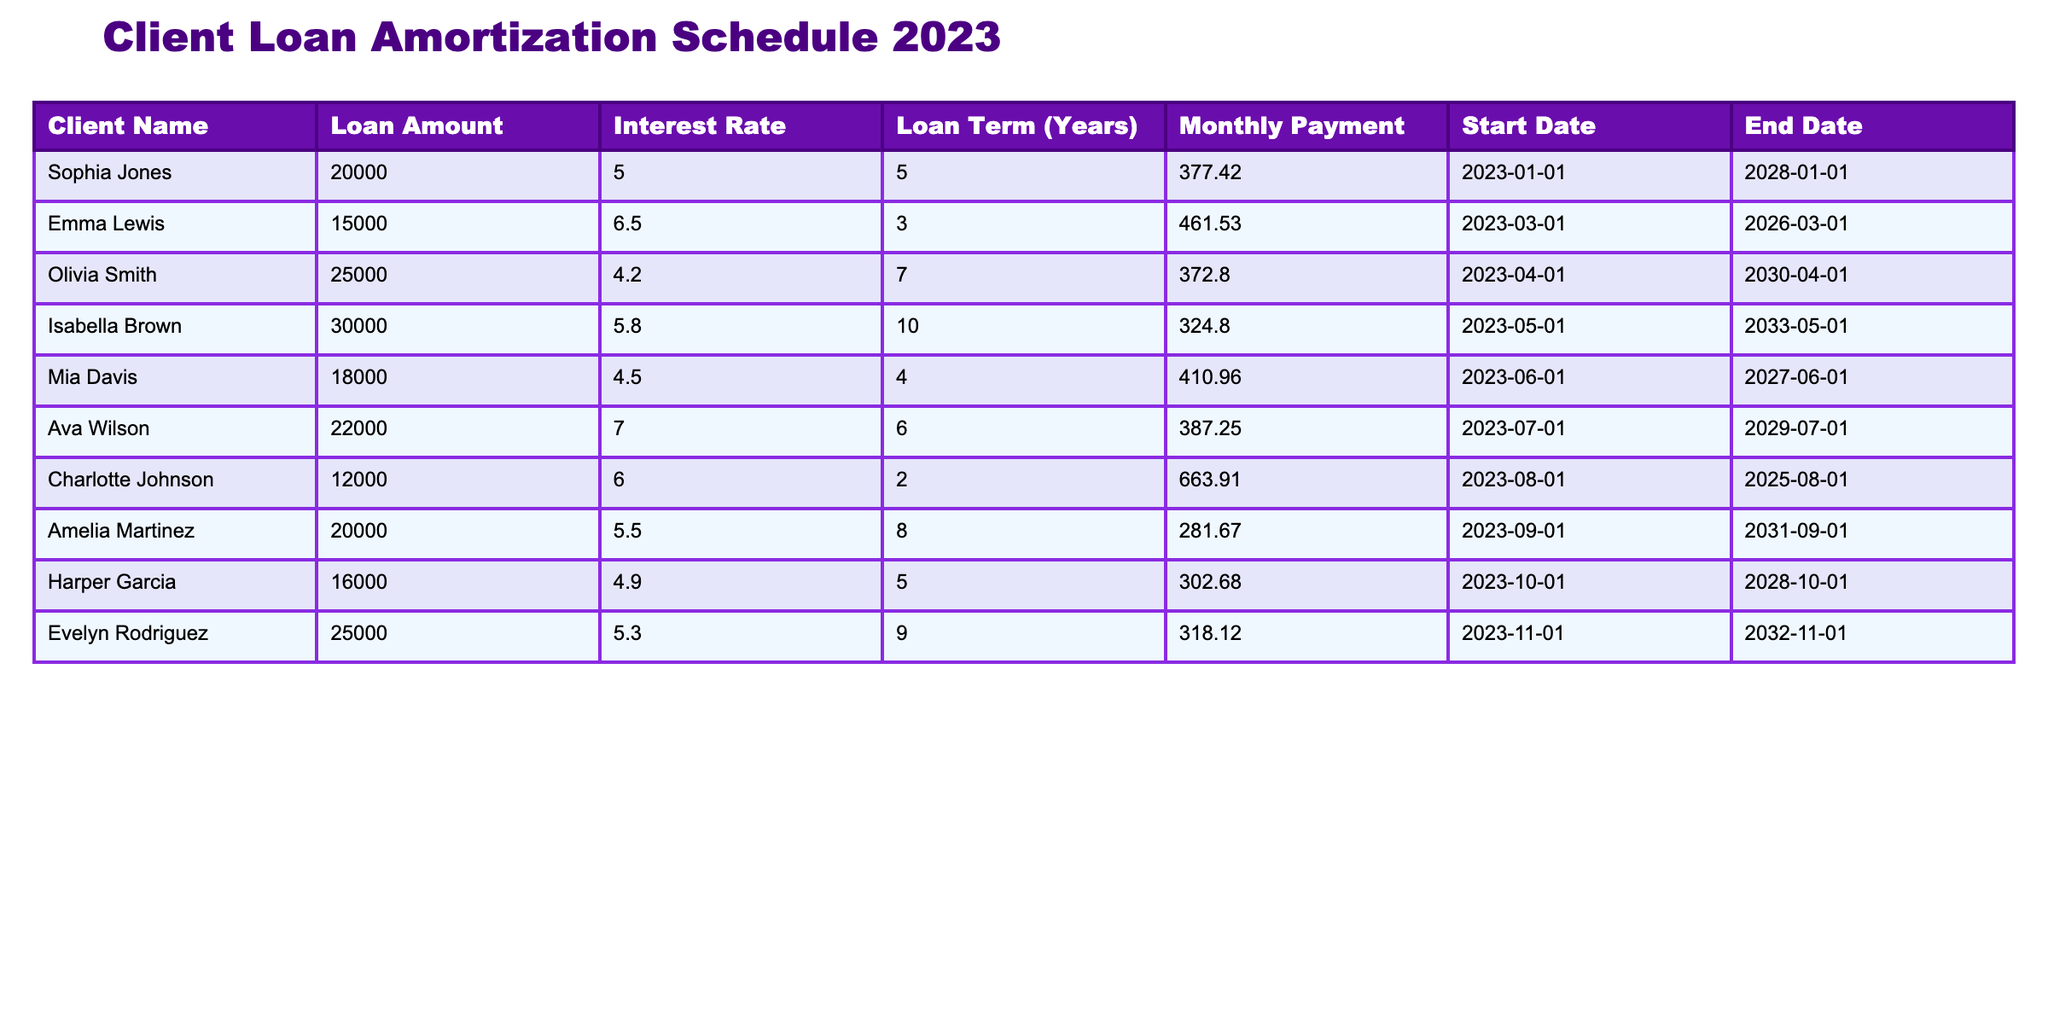What is the loan amount for Emma Lewis? The table lists the loan amounts for each client. Looking at Emma Lewis's row, her loan amount is clearly stated as 15000.
Answer: 15000 What is the monthly payment for Sophia Jones? To find this, we simply look at Sophia Jones's row in the table, where the monthly payment is noted as 377.42.
Answer: 377.42 Which client has the longest loan term? The loan terms are listed in years for each client. By scanning through the loan term, Isabella Brown has a loan term of 10 years, which is the longest compared to others.
Answer: Isabella Brown What is the total loan amount for all clients? We sum the loan amounts listed in the table: 20000 + 15000 + 25000 + 30000 + 18000 + 22000 + 12000 + 20000 + 16000 + 25000 = 188000. Therefore, the total loan amount for all clients is 188000.
Answer: 188000 Is Charlotte Johnson's interest rate higher than 5%? We can check Charlotte Johnson's row for her interest rate, which is noted as 6.0%. Since 6.0% is greater than 5%, the answer is yes.
Answer: Yes Which client has the highest monthly payment? By comparing the monthly payments of all clients listed, we can determine that Charlotte Johnson has the highest monthly payment of 663.91, which stands out compared to others.
Answer: Charlotte Johnson What is the average interest rate across all clients? To find the average, we must sum all the interest rates: (5.0 + 6.5 + 4.2 + 5.8 + 4.5 + 7.0 + 6.0 + 5.5 + 4.9 + 5.3) and divide by the number of clients (10). The sum equals 57.7, and dividing that by 10 gives us an average interest rate of 5.77.
Answer: 5.77 Does any client have a loan amount below 20000? Looking through the loan amounts, we see that Charlotte Johnson has a loan amount of 12000, which is below 20000. Therefore, the answer is yes.
Answer: Yes If Mia Davis paid off her loan early, how many months would she still have left? Mia's loan term is 4 years, and she started her loan in June 2023, which means it will end in June 2027. Since we are currently still in 2023, she has 3 years left, which is 36 months.
Answer: 36 months 